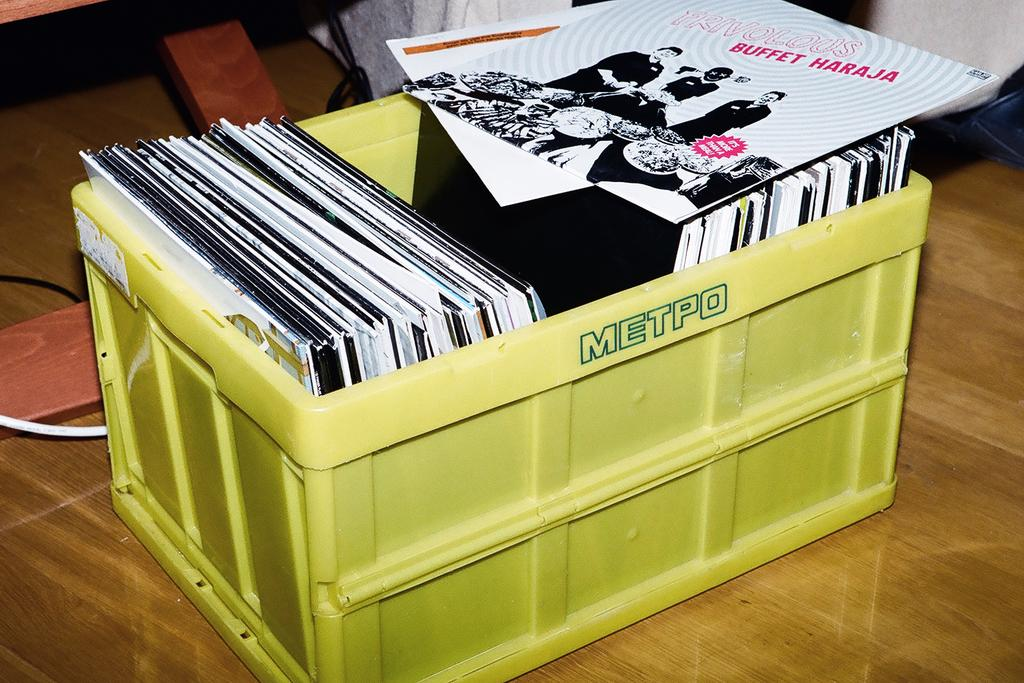<image>
Offer a succinct explanation of the picture presented. A yellow metpo box with and album named "Buffet Haraja". 